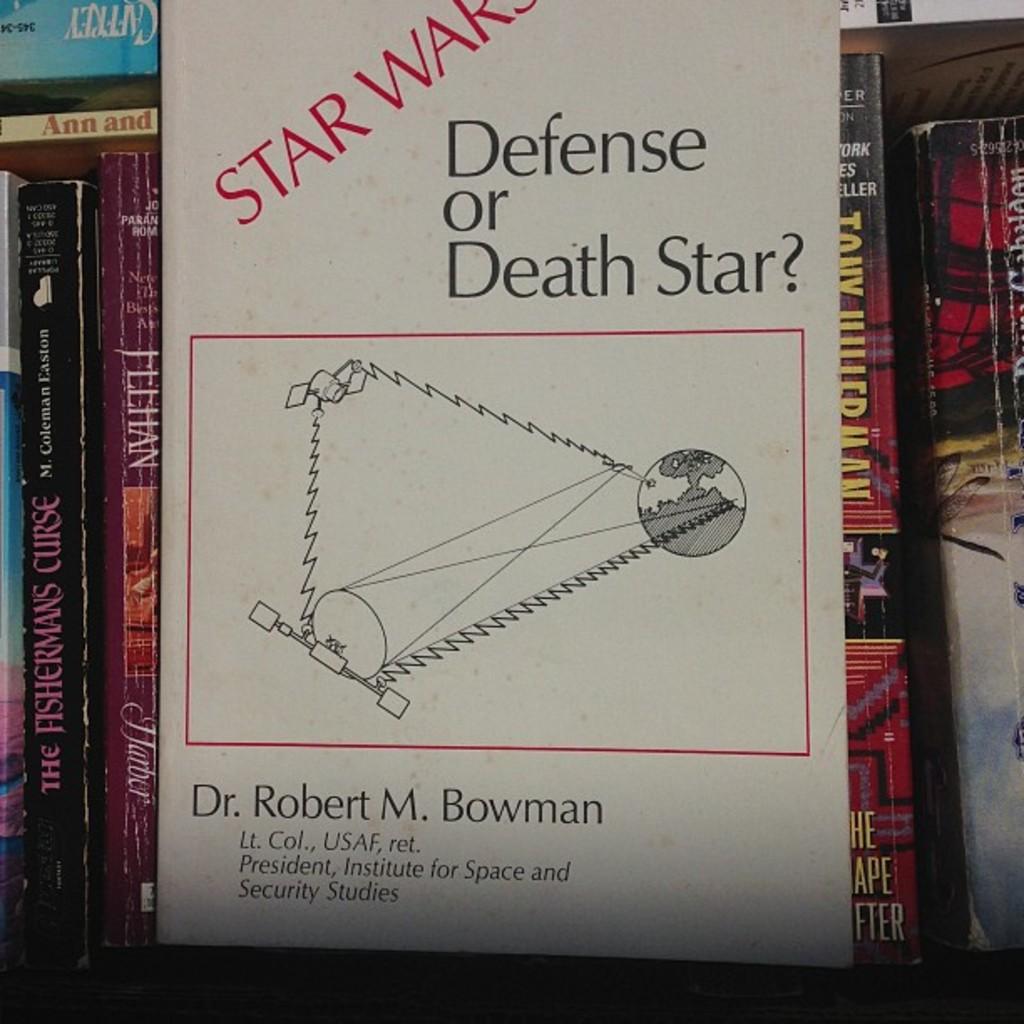What´s the author of this book?
Your response must be concise. Dr. robert m. bowman. 